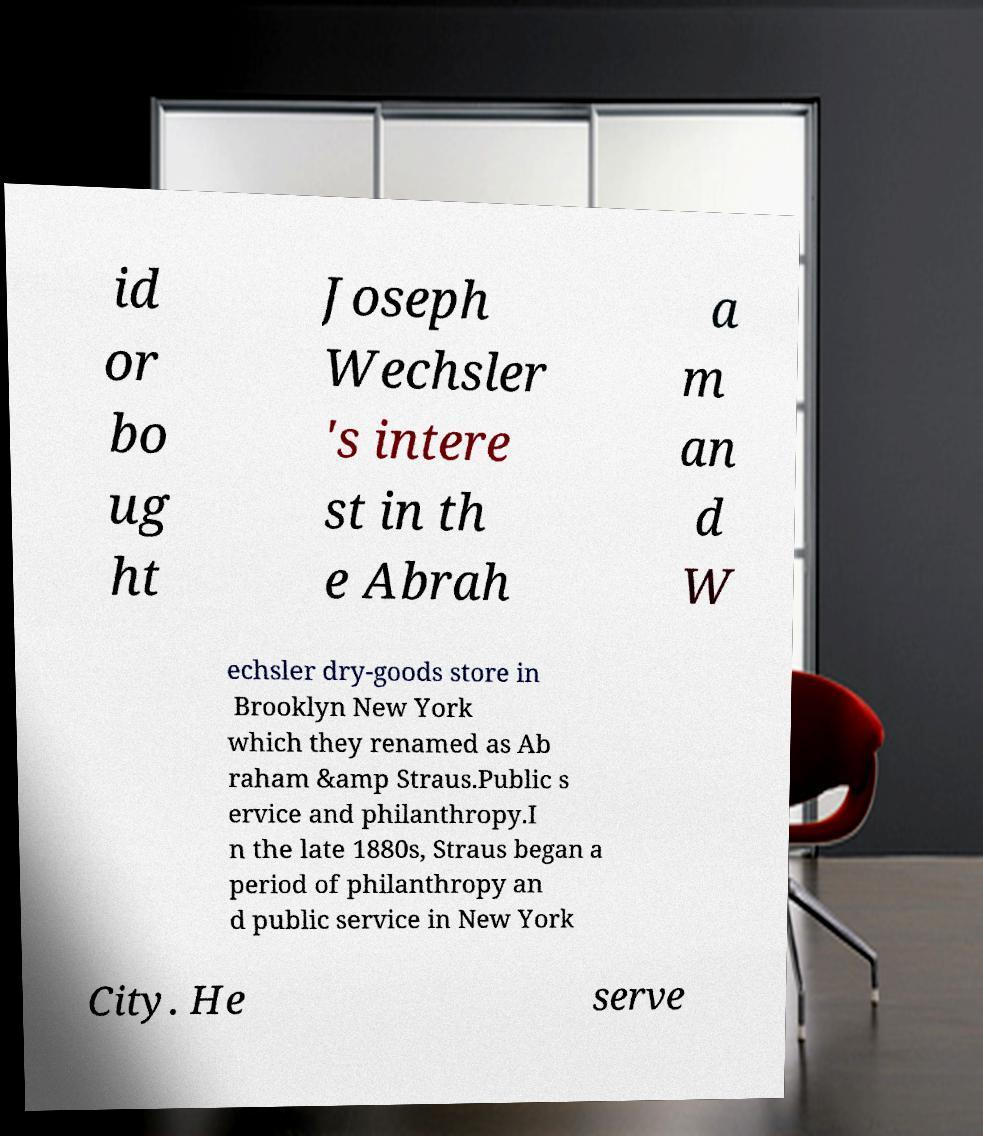Please read and relay the text visible in this image. What does it say? id or bo ug ht Joseph Wechsler 's intere st in th e Abrah a m an d W echsler dry-goods store in Brooklyn New York which they renamed as Ab raham &amp Straus.Public s ervice and philanthropy.I n the late 1880s, Straus began a period of philanthropy an d public service in New York City. He serve 